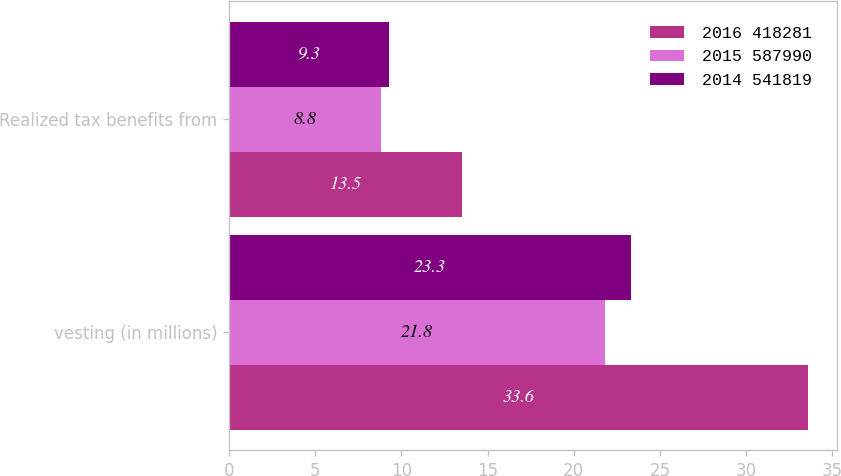Convert chart. <chart><loc_0><loc_0><loc_500><loc_500><stacked_bar_chart><ecel><fcel>vesting (in millions)<fcel>Realized tax benefits from<nl><fcel>2016 418281<fcel>33.6<fcel>13.5<nl><fcel>2015 587990<fcel>21.8<fcel>8.8<nl><fcel>2014 541819<fcel>23.3<fcel>9.3<nl></chart> 